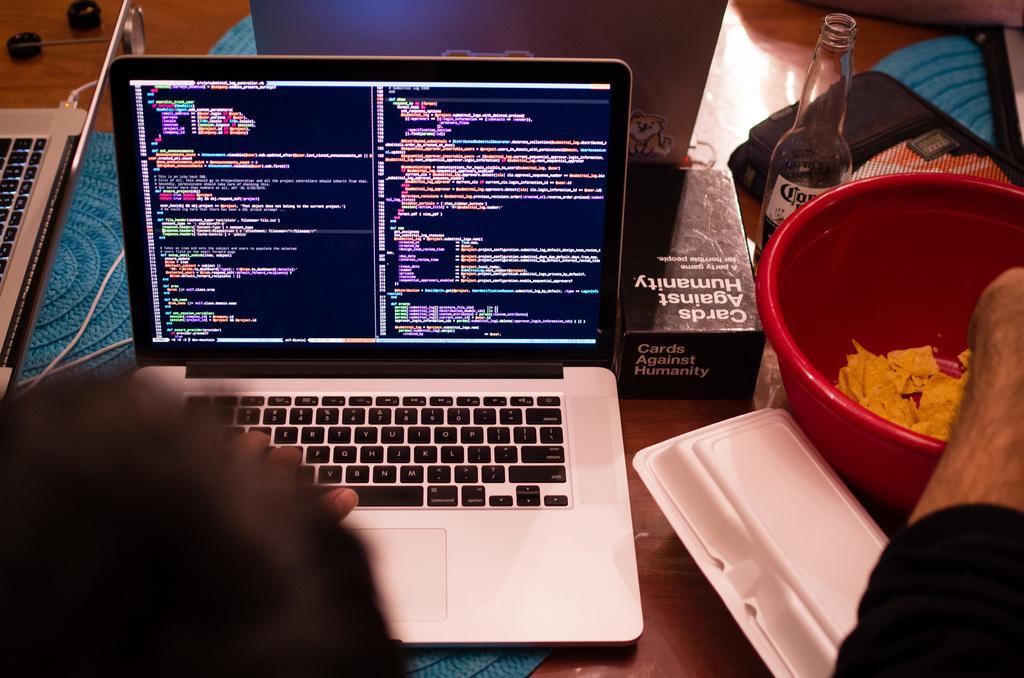In one or two sentences, can you explain what this image depicts? There is a laptop and bowl with chips in it and a cool drink bottle. 